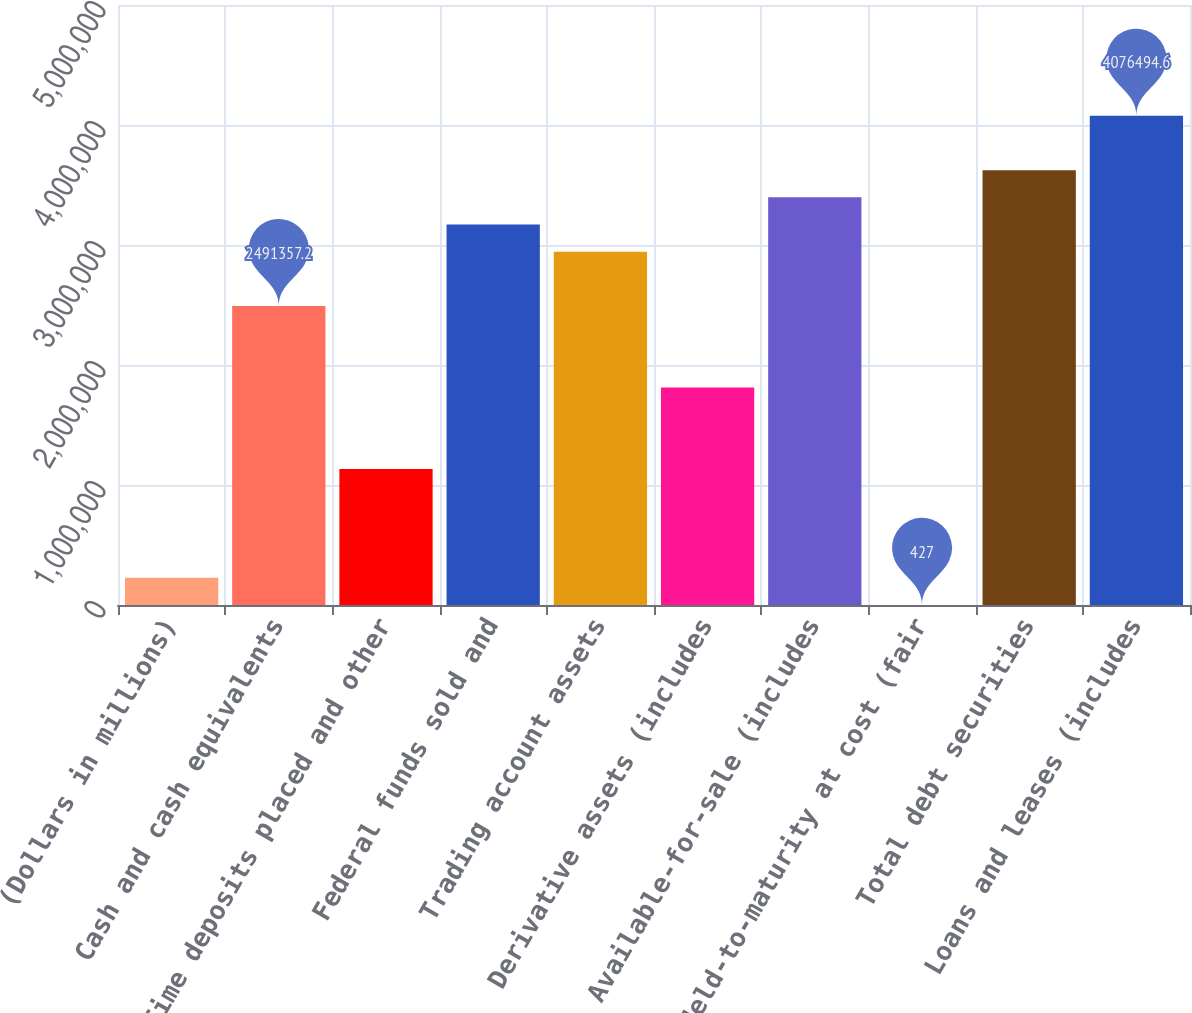<chart> <loc_0><loc_0><loc_500><loc_500><bar_chart><fcel>(Dollars in millions)<fcel>Cash and cash equivalents<fcel>Time deposits placed and other<fcel>Federal funds sold and<fcel>Trading account assets<fcel>Derivative assets (includes<fcel>Available-for-sale (includes<fcel>Held-to-maturity at cost (fair<fcel>Total debt securities<fcel>Loans and leases (includes<nl><fcel>226875<fcel>2.49136e+06<fcel>1.13267e+06<fcel>3.1707e+06<fcel>2.94425e+06<fcel>1.81201e+06<fcel>3.39715e+06<fcel>427<fcel>3.6236e+06<fcel>4.07649e+06<nl></chart> 